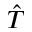<formula> <loc_0><loc_0><loc_500><loc_500>\hat { T }</formula> 